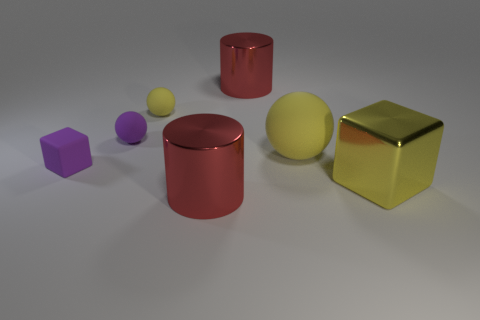Is the number of blocks to the right of the tiny yellow thing the same as the number of yellow rubber things that are in front of the small purple cube?
Make the answer very short. No. What is the tiny purple block made of?
Provide a short and direct response. Rubber. What is the material of the cube to the left of the yellow block?
Your response must be concise. Rubber. Is the number of large cubes to the right of the big rubber object greater than the number of tiny cyan shiny cylinders?
Offer a terse response. Yes. There is a tiny purple matte cube that is behind the large red cylinder in front of the yellow metallic thing; are there any large blocks in front of it?
Your response must be concise. Yes. There is a matte cube; are there any cylinders left of it?
Make the answer very short. No. How many other shiny cubes have the same color as the tiny cube?
Your answer should be very brief. 0. What is the size of the purple cube that is the same material as the small purple ball?
Offer a very short reply. Small. What size is the yellow sphere that is to the left of the big yellow object that is behind the big shiny block that is in front of the purple rubber ball?
Your answer should be very brief. Small. There is a red metal cylinder in front of the purple matte cube; how big is it?
Make the answer very short. Large. 